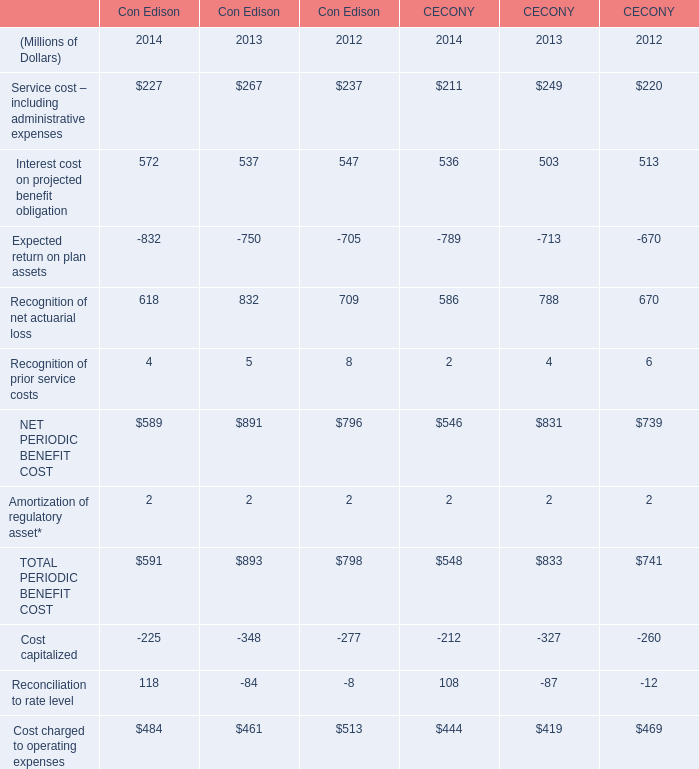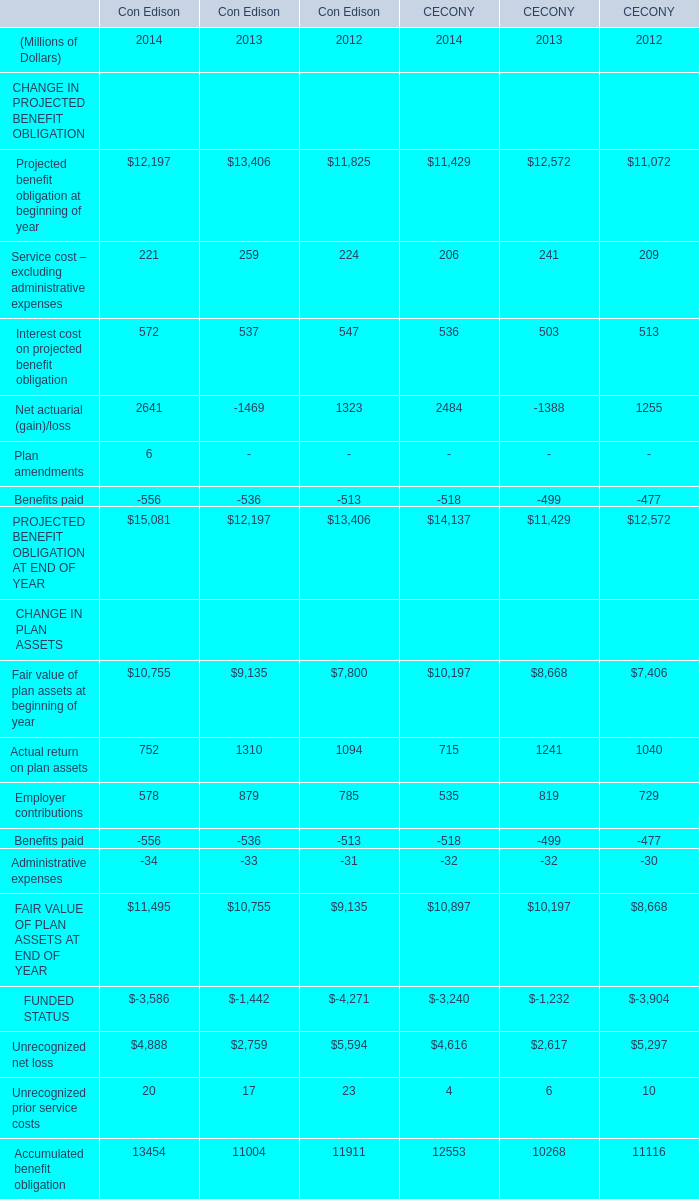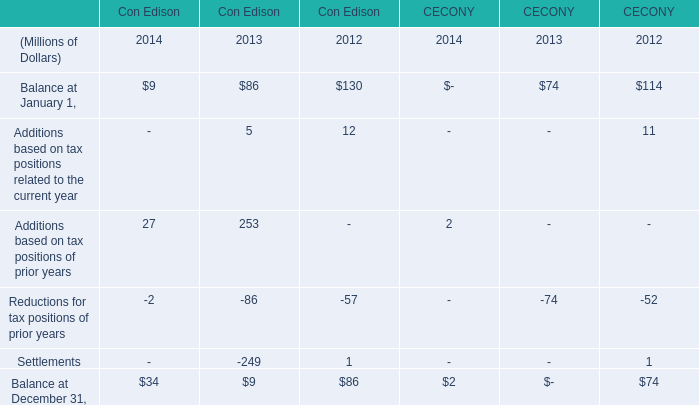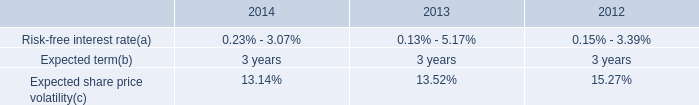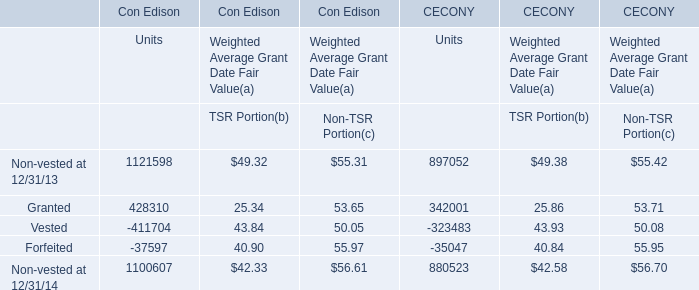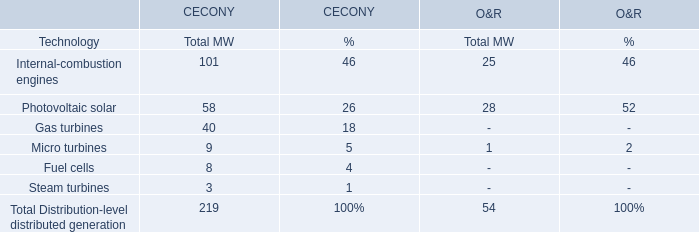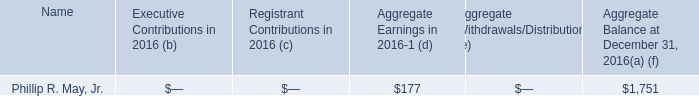what is the percentage change in the aggregate balance from 2015 to 2016 for phillip r . may jr.? 
Computations: (177 / (1751 - 177))
Answer: 0.11245. 